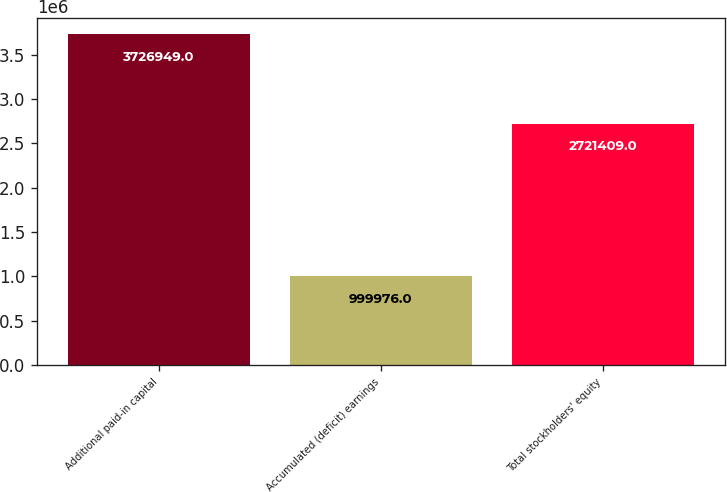Convert chart. <chart><loc_0><loc_0><loc_500><loc_500><bar_chart><fcel>Additional paid-in capital<fcel>Accumulated (deficit) earnings<fcel>Total stockholders' equity<nl><fcel>3.72695e+06<fcel>999976<fcel>2.72141e+06<nl></chart> 